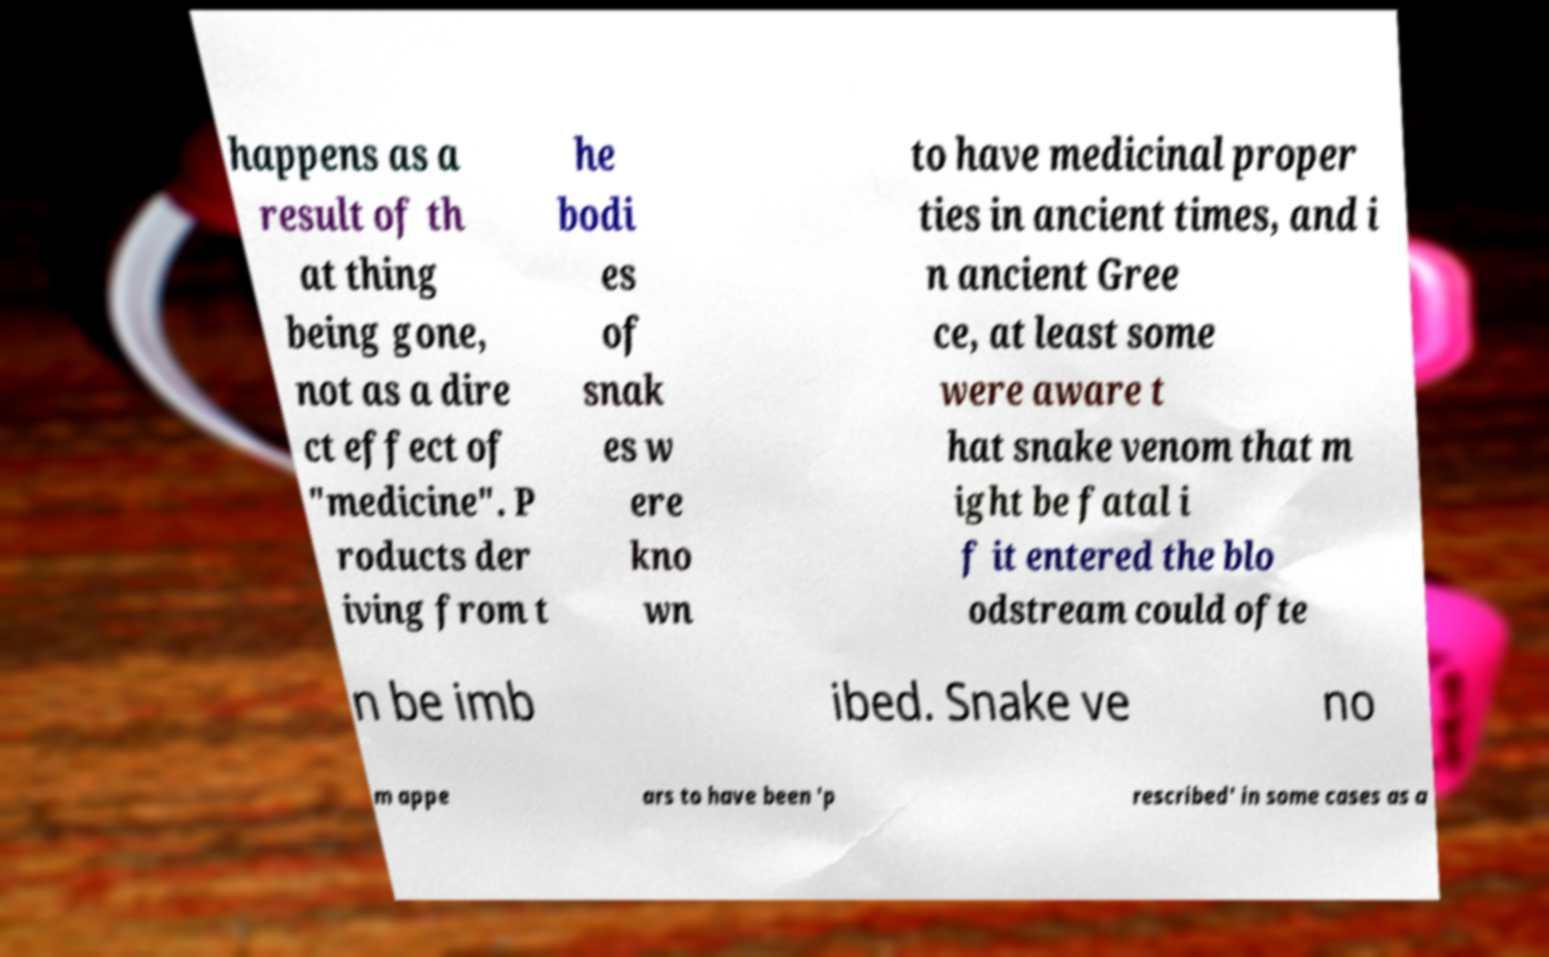There's text embedded in this image that I need extracted. Can you transcribe it verbatim? happens as a result of th at thing being gone, not as a dire ct effect of "medicine". P roducts der iving from t he bodi es of snak es w ere kno wn to have medicinal proper ties in ancient times, and i n ancient Gree ce, at least some were aware t hat snake venom that m ight be fatal i f it entered the blo odstream could ofte n be imb ibed. Snake ve no m appe ars to have been 'p rescribed' in some cases as a 